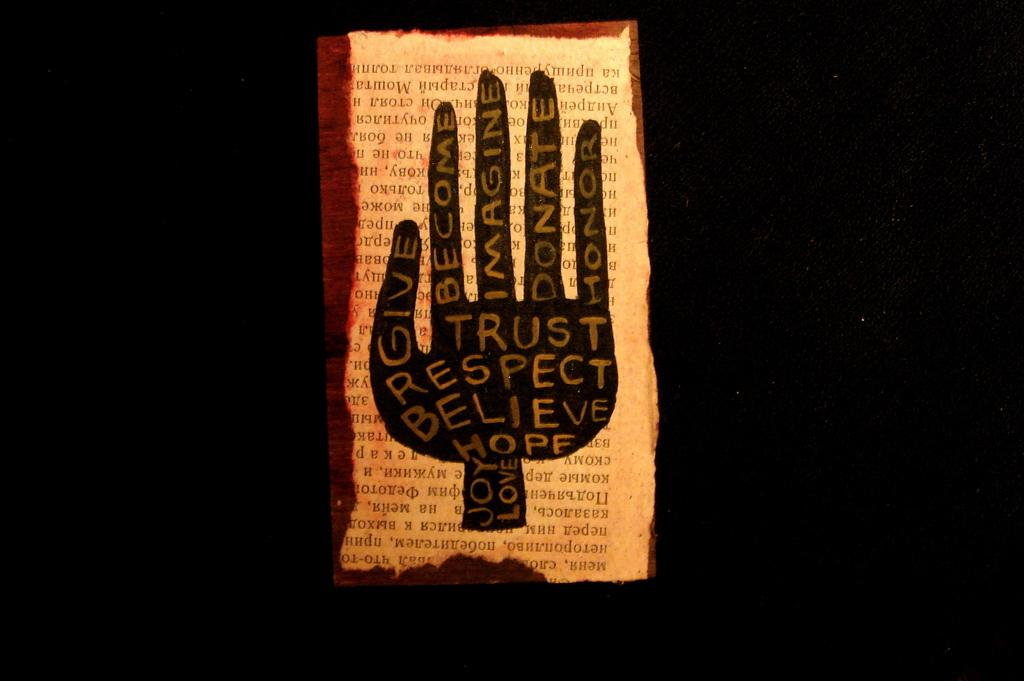<image>
Share a concise interpretation of the image provided. A book page features a black hand with the word trust on it. 